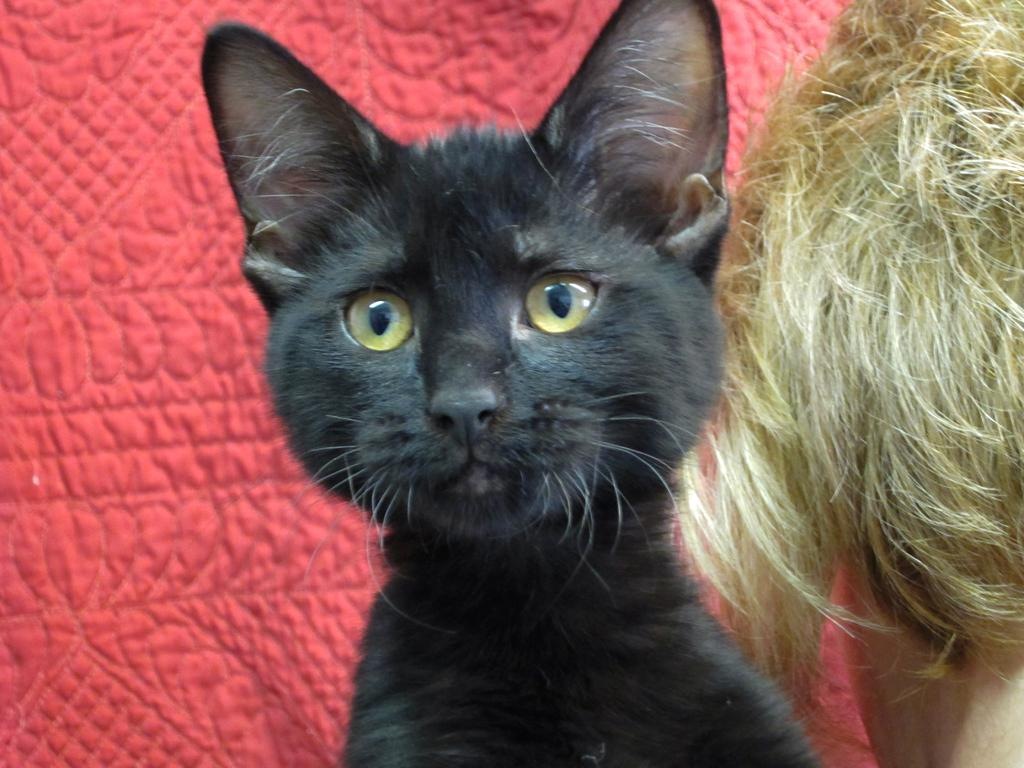What type of animal is in the image? There is a cat in the image. What other living being is in the image? There is a human in the image. Where are the cat and the human located in the image? Both the cat and the human are on the right side of the image. What color is the cloth in the background of the image? There is a red color cloth in the background of the image. What month is it in the image? The month cannot be determined from the image, as there is no information about the time of year. Is there any sand visible in the image? There is no sand present in the image. 